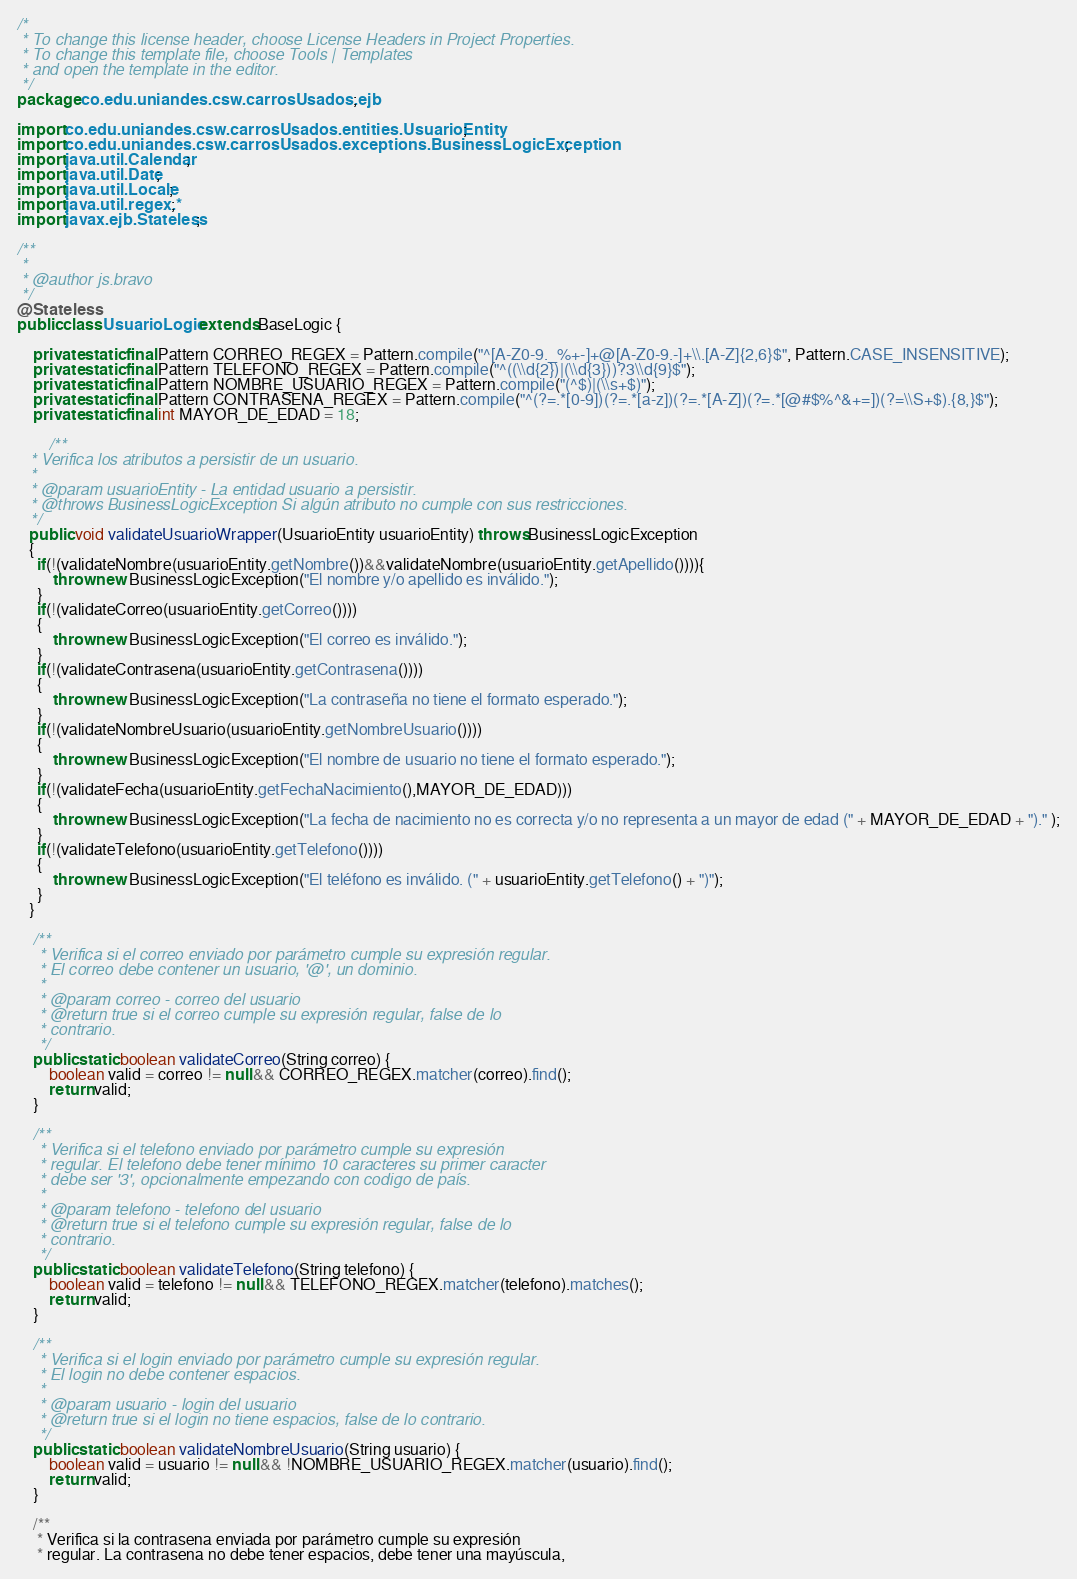Convert code to text. <code><loc_0><loc_0><loc_500><loc_500><_Java_>/*
 * To change this license header, choose License Headers in Project Properties.
 * To change this template file, choose Tools | Templates
 * and open the template in the editor.
 */
package co.edu.uniandes.csw.carrosUsados.ejb;

import co.edu.uniandes.csw.carrosUsados.entities.UsuarioEntity;
import co.edu.uniandes.csw.carrosUsados.exceptions.BusinessLogicException;
import java.util.Calendar;
import java.util.Date;
import java.util.Locale;
import java.util.regex.*;
import javax.ejb.Stateless;

/**
 *
 * @author js.bravo
 */
@Stateless
public class UsuarioLogic extends BaseLogic {

    private static final Pattern CORREO_REGEX = Pattern.compile("^[A-Z0-9._%+-]+@[A-Z0-9.-]+\\.[A-Z]{2,6}$", Pattern.CASE_INSENSITIVE);
    private static final Pattern TELEFONO_REGEX = Pattern.compile("^((\\d{2})|(\\d{3}))?3\\d{9}$");
    private static final Pattern NOMBRE_USUARIO_REGEX = Pattern.compile("(^$)|(\\s+$)");
    private static final Pattern CONTRASENA_REGEX = Pattern.compile("^(?=.*[0-9])(?=.*[a-z])(?=.*[A-Z])(?=.*[@#$%^&+=])(?=\\S+$).{8,}$");
    private static final int MAYOR_DE_EDAD = 18;
    
        /**
   * Verifica los atributos a persistir de un usuario.
   *
   * @param usuarioEntity - La entidad usuario a persistir.
   * @throws BusinessLogicException Si algún atributo no cumple con sus restricciones.
   */
   public void validateUsuarioWrapper(UsuarioEntity usuarioEntity) throws BusinessLogicException
   {
     if(!(validateNombre(usuarioEntity.getNombre())&&validateNombre(usuarioEntity.getApellido()))){
         throw new BusinessLogicException("El nombre y/o apellido es inválido.");
     }
     if(!(validateCorreo(usuarioEntity.getCorreo())))
     {
         throw new BusinessLogicException("El correo es inválido.");
     }
     if(!(validateContrasena(usuarioEntity.getContrasena())))
     {
         throw new BusinessLogicException("La contraseña no tiene el formato esperado.");
     }
     if(!(validateNombreUsuario(usuarioEntity.getNombreUsuario())))
     {
         throw new BusinessLogicException("El nombre de usuario no tiene el formato esperado.");
     }
     if(!(validateFecha(usuarioEntity.getFechaNacimiento(),MAYOR_DE_EDAD)))
     {
         throw new BusinessLogicException("La fecha de nacimiento no es correcta y/o no representa a un mayor de edad (" + MAYOR_DE_EDAD + ")." );
     }
     if(!(validateTelefono(usuarioEntity.getTelefono())))
     {
         throw new BusinessLogicException("El teléfono es inválido. (" + usuarioEntity.getTelefono() + ")");
     }
   }

    /**
     * Verifica si el correo enviado por parámetro cumple su expresión regular.
     * El correo debe contener un usuario, '@', un dominio.
     *
     * @param correo - correo del usuario
     * @return true si el correo cumple su expresión regular, false de lo
     * contrario.
     */
    public static boolean validateCorreo(String correo) {
        boolean valid = correo != null && CORREO_REGEX.matcher(correo).find();
        return valid;
    }

    /**
     * Verifica si el telefono enviado por parámetro cumple su expresión
     * regular. El telefono debe tener mínimo 10 caracteres su primer caracter
     * debe ser '3', opcionalmente empezando con codigo de país.
     *
     * @param telefono - telefono del usuario
     * @return true si el telefono cumple su expresión regular, false de lo
     * contrario.
     */
    public static boolean validateTelefono(String telefono) {
        boolean valid = telefono != null && TELEFONO_REGEX.matcher(telefono).matches();
        return valid;
    }

    /**
     * Verifica si el login enviado por parámetro cumple su expresión regular.
     * El login no debe contener espacios.
     *
     * @param usuario - login del usuario
     * @return true si el login no tiene espacios, false de lo contrario.
     */
    public static boolean validateNombreUsuario(String usuario) {
        boolean valid = usuario != null && !NOMBRE_USUARIO_REGEX.matcher(usuario).find();
        return valid;
    }

    /**
     * Verifica si la contrasena enviada por parámetro cumple su expresión
     * regular. La contrasena no debe tener espacios, debe tener una mayúscula,</code> 